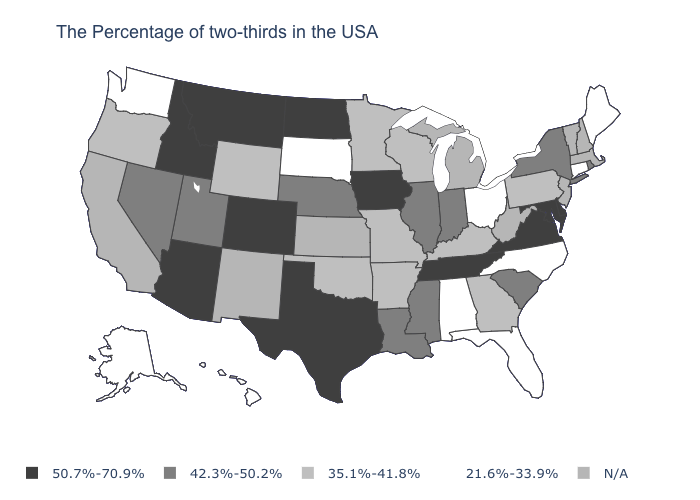What is the value of Mississippi?
Short answer required. 42.3%-50.2%. What is the value of New Hampshire?
Short answer required. N/A. What is the value of Utah?
Be succinct. 42.3%-50.2%. What is the value of New Mexico?
Answer briefly. N/A. What is the value of Connecticut?
Be succinct. 21.6%-33.9%. Name the states that have a value in the range 35.1%-41.8%?
Answer briefly. Pennsylvania, Georgia, Kentucky, Wisconsin, Missouri, Arkansas, Minnesota, Oklahoma, Wyoming, Oregon. Which states have the highest value in the USA?
Write a very short answer. Delaware, Maryland, Virginia, Tennessee, Iowa, Texas, North Dakota, Colorado, Montana, Arizona, Idaho. Name the states that have a value in the range 21.6%-33.9%?
Answer briefly. Maine, Connecticut, North Carolina, Ohio, Florida, Alabama, South Dakota, Washington, Alaska, Hawaii. What is the value of West Virginia?
Keep it brief. N/A. Name the states that have a value in the range 21.6%-33.9%?
Answer briefly. Maine, Connecticut, North Carolina, Ohio, Florida, Alabama, South Dakota, Washington, Alaska, Hawaii. Is the legend a continuous bar?
Keep it brief. No. What is the lowest value in states that border North Dakota?
Write a very short answer. 21.6%-33.9%. What is the value of Arkansas?
Quick response, please. 35.1%-41.8%. What is the lowest value in the USA?
Quick response, please. 21.6%-33.9%. 